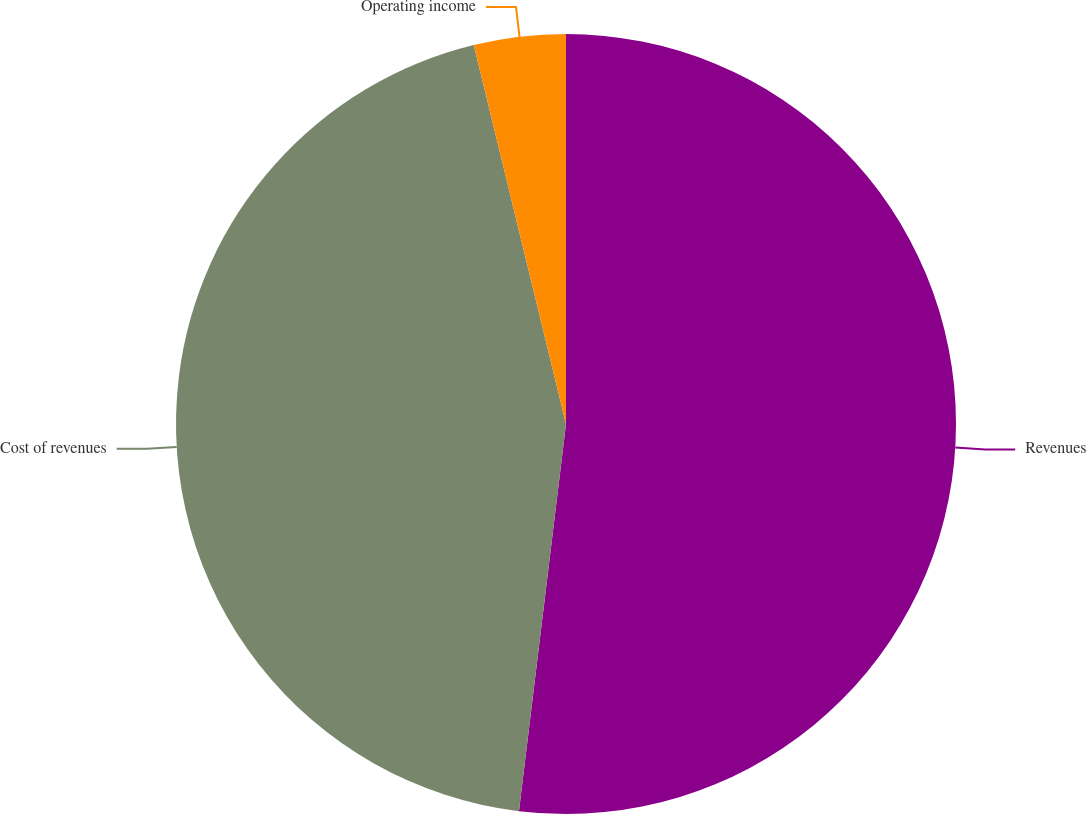Convert chart. <chart><loc_0><loc_0><loc_500><loc_500><pie_chart><fcel>Revenues<fcel>Cost of revenues<fcel>Operating income<nl><fcel>51.92%<fcel>44.27%<fcel>3.8%<nl></chart> 